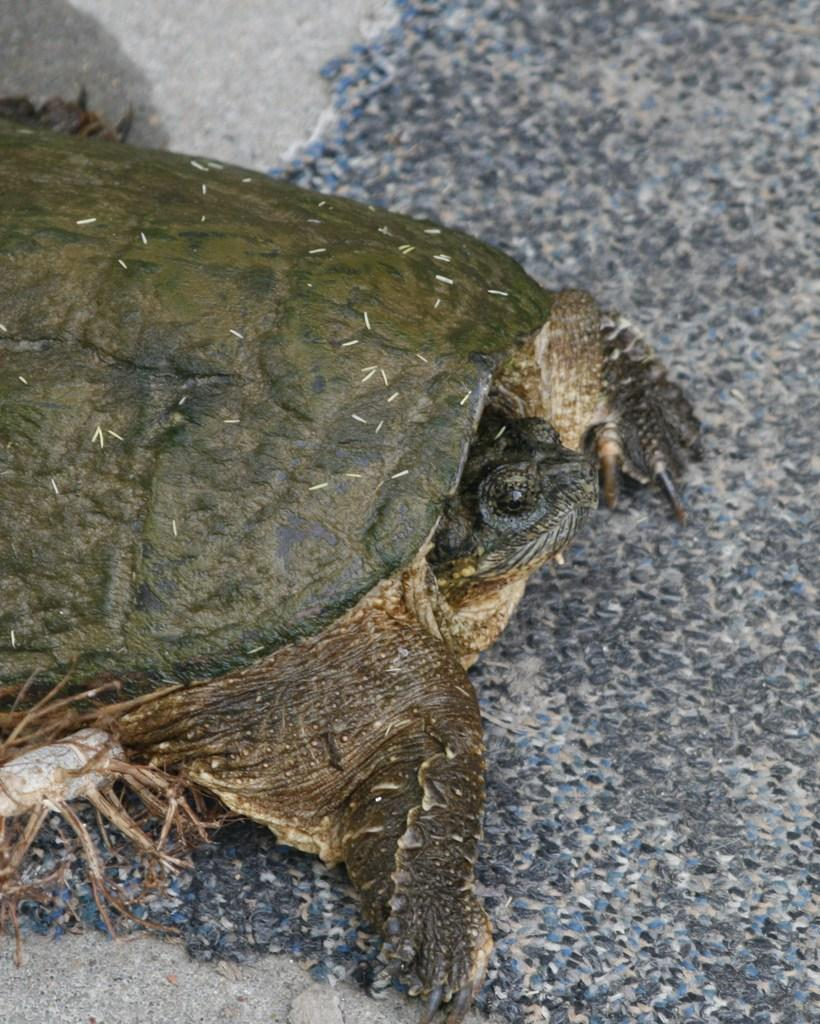What type of animal is present in the image? There is a turtle in the image. What type of beast is depicted on the quilt in the image? There is no quilt or beast present in the image; it features a turtle. How does the turtle show respect in the image? The turtle does not show respect in the image, as it is an animal and does not have the ability to express emotions or actions related to respect. 